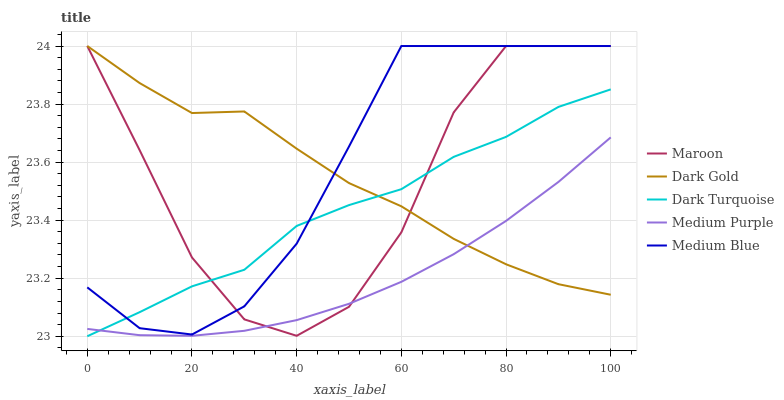Does Medium Purple have the minimum area under the curve?
Answer yes or no. Yes. Does Medium Blue have the maximum area under the curve?
Answer yes or no. Yes. Does Dark Turquoise have the minimum area under the curve?
Answer yes or no. No. Does Dark Turquoise have the maximum area under the curve?
Answer yes or no. No. Is Medium Purple the smoothest?
Answer yes or no. Yes. Is Maroon the roughest?
Answer yes or no. Yes. Is Dark Turquoise the smoothest?
Answer yes or no. No. Is Dark Turquoise the roughest?
Answer yes or no. No. Does Dark Turquoise have the lowest value?
Answer yes or no. Yes. Does Medium Blue have the lowest value?
Answer yes or no. No. Does Dark Gold have the highest value?
Answer yes or no. Yes. Does Dark Turquoise have the highest value?
Answer yes or no. No. Is Medium Purple less than Medium Blue?
Answer yes or no. Yes. Is Medium Blue greater than Medium Purple?
Answer yes or no. Yes. Does Medium Purple intersect Maroon?
Answer yes or no. Yes. Is Medium Purple less than Maroon?
Answer yes or no. No. Is Medium Purple greater than Maroon?
Answer yes or no. No. Does Medium Purple intersect Medium Blue?
Answer yes or no. No. 